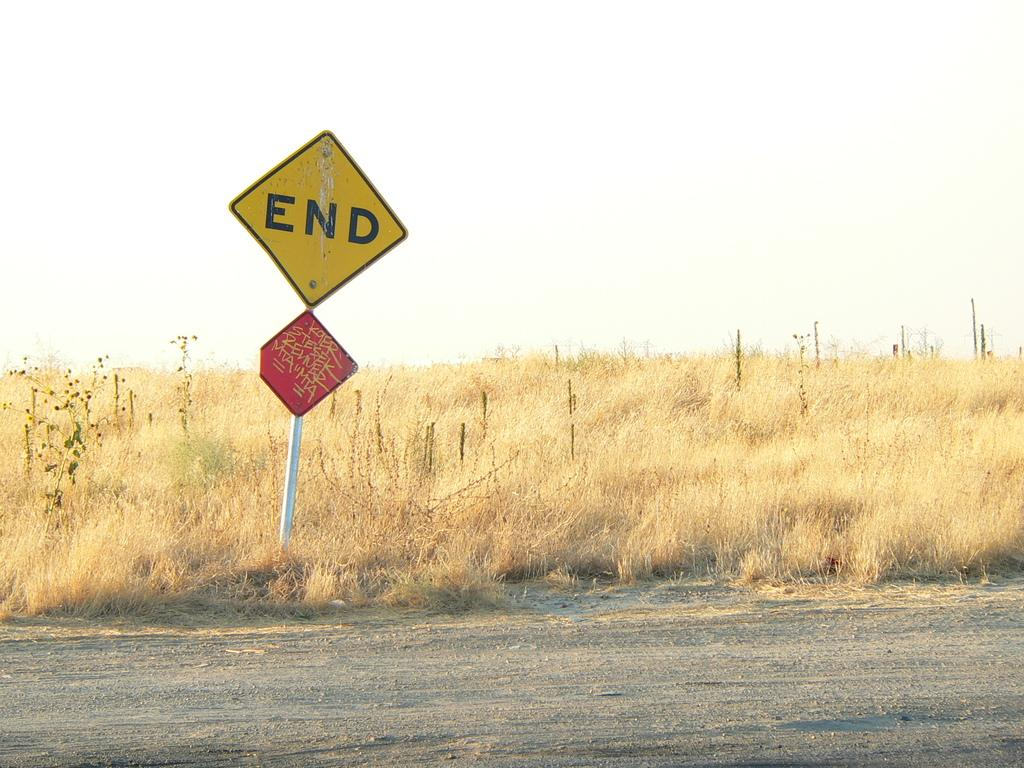<image>
Present a compact description of the photo's key features. A sign saying end next to an overgrown field 